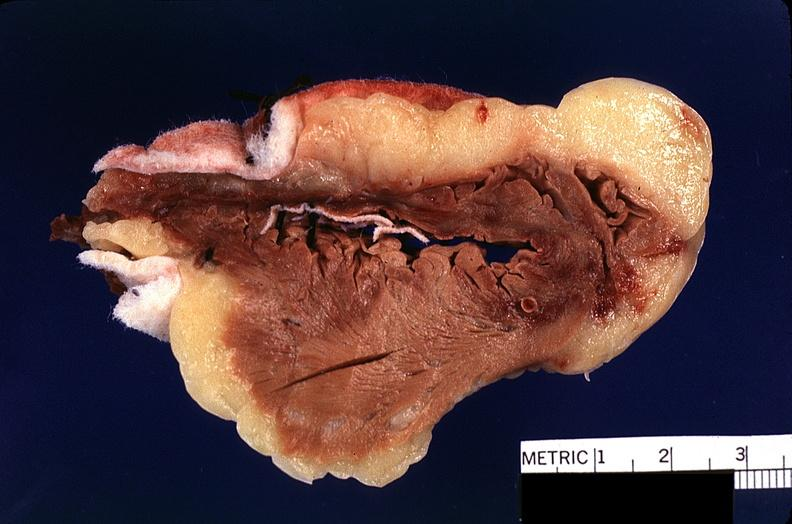does side show heart, myocardial infarction, surgery to repair interventricular septum rupture?
Answer the question using a single word or phrase. No 